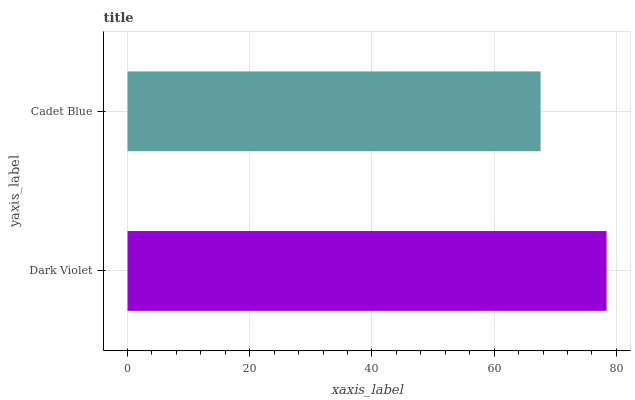Is Cadet Blue the minimum?
Answer yes or no. Yes. Is Dark Violet the maximum?
Answer yes or no. Yes. Is Cadet Blue the maximum?
Answer yes or no. No. Is Dark Violet greater than Cadet Blue?
Answer yes or no. Yes. Is Cadet Blue less than Dark Violet?
Answer yes or no. Yes. Is Cadet Blue greater than Dark Violet?
Answer yes or no. No. Is Dark Violet less than Cadet Blue?
Answer yes or no. No. Is Dark Violet the high median?
Answer yes or no. Yes. Is Cadet Blue the low median?
Answer yes or no. Yes. Is Cadet Blue the high median?
Answer yes or no. No. Is Dark Violet the low median?
Answer yes or no. No. 